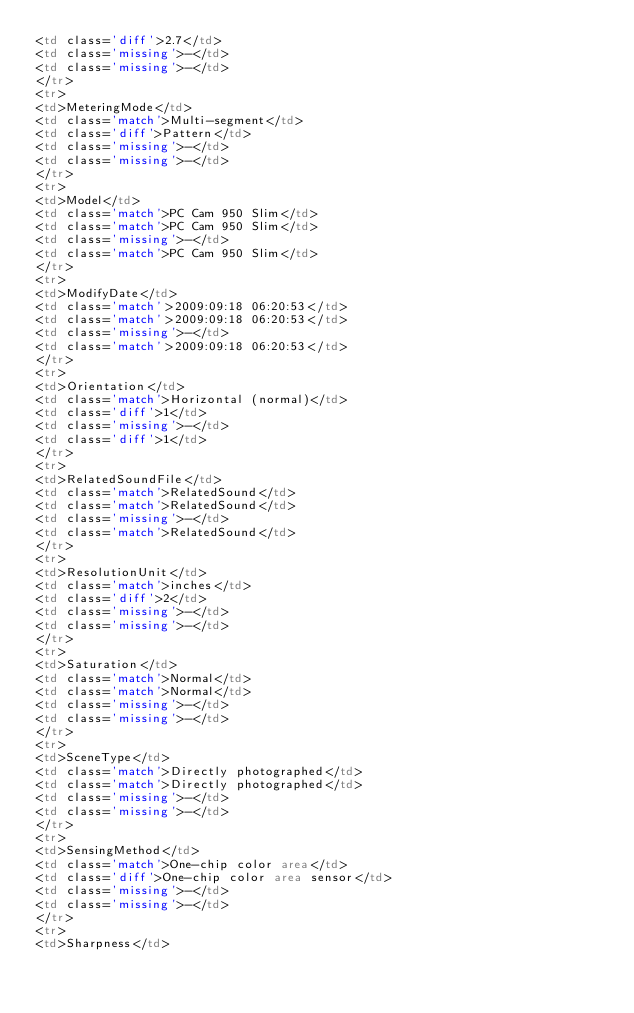Convert code to text. <code><loc_0><loc_0><loc_500><loc_500><_HTML_><td class='diff'>2.7</td>
<td class='missing'>-</td>
<td class='missing'>-</td>
</tr>
<tr>
<td>MeteringMode</td>
<td class='match'>Multi-segment</td>
<td class='diff'>Pattern</td>
<td class='missing'>-</td>
<td class='missing'>-</td>
</tr>
<tr>
<td>Model</td>
<td class='match'>PC Cam 950 Slim</td>
<td class='match'>PC Cam 950 Slim</td>
<td class='missing'>-</td>
<td class='match'>PC Cam 950 Slim</td>
</tr>
<tr>
<td>ModifyDate</td>
<td class='match'>2009:09:18 06:20:53</td>
<td class='match'>2009:09:18 06:20:53</td>
<td class='missing'>-</td>
<td class='match'>2009:09:18 06:20:53</td>
</tr>
<tr>
<td>Orientation</td>
<td class='match'>Horizontal (normal)</td>
<td class='diff'>1</td>
<td class='missing'>-</td>
<td class='diff'>1</td>
</tr>
<tr>
<td>RelatedSoundFile</td>
<td class='match'>RelatedSound</td>
<td class='match'>RelatedSound</td>
<td class='missing'>-</td>
<td class='match'>RelatedSound</td>
</tr>
<tr>
<td>ResolutionUnit</td>
<td class='match'>inches</td>
<td class='diff'>2</td>
<td class='missing'>-</td>
<td class='missing'>-</td>
</tr>
<tr>
<td>Saturation</td>
<td class='match'>Normal</td>
<td class='match'>Normal</td>
<td class='missing'>-</td>
<td class='missing'>-</td>
</tr>
<tr>
<td>SceneType</td>
<td class='match'>Directly photographed</td>
<td class='match'>Directly photographed</td>
<td class='missing'>-</td>
<td class='missing'>-</td>
</tr>
<tr>
<td>SensingMethod</td>
<td class='match'>One-chip color area</td>
<td class='diff'>One-chip color area sensor</td>
<td class='missing'>-</td>
<td class='missing'>-</td>
</tr>
<tr>
<td>Sharpness</td></code> 